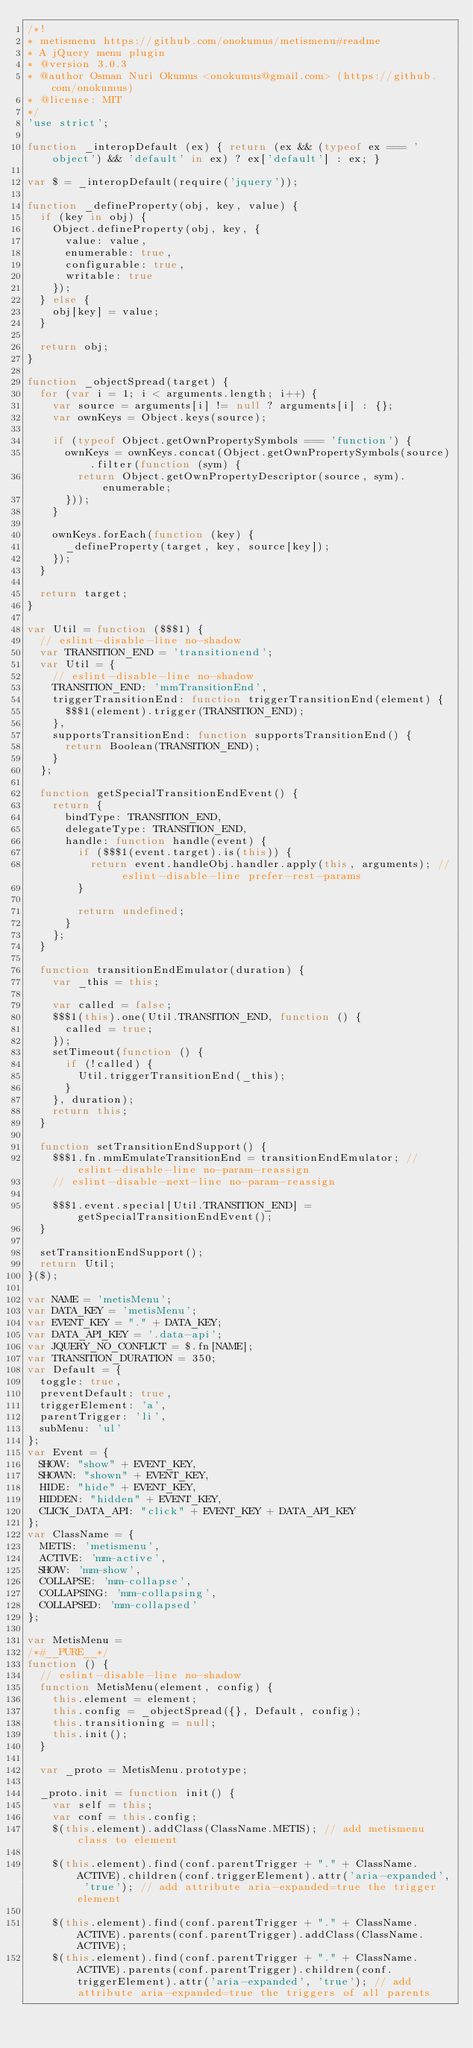<code> <loc_0><loc_0><loc_500><loc_500><_JavaScript_>/*!
* metismenu https://github.com/onokumus/metismenu#readme
* A jQuery menu plugin
* @version 3.0.3
* @author Osman Nuri Okumus <onokumus@gmail.com> (https://github.com/onokumus)
* @license: MIT 
*/
'use strict';

function _interopDefault (ex) { return (ex && (typeof ex === 'object') && 'default' in ex) ? ex['default'] : ex; }

var $ = _interopDefault(require('jquery'));

function _defineProperty(obj, key, value) {
  if (key in obj) {
    Object.defineProperty(obj, key, {
      value: value,
      enumerable: true,
      configurable: true,
      writable: true
    });
  } else {
    obj[key] = value;
  }

  return obj;
}

function _objectSpread(target) {
  for (var i = 1; i < arguments.length; i++) {
    var source = arguments[i] != null ? arguments[i] : {};
    var ownKeys = Object.keys(source);

    if (typeof Object.getOwnPropertySymbols === 'function') {
      ownKeys = ownKeys.concat(Object.getOwnPropertySymbols(source).filter(function (sym) {
        return Object.getOwnPropertyDescriptor(source, sym).enumerable;
      }));
    }

    ownKeys.forEach(function (key) {
      _defineProperty(target, key, source[key]);
    });
  }

  return target;
}

var Util = function ($$$1) {
  // eslint-disable-line no-shadow
  var TRANSITION_END = 'transitionend';
  var Util = {
    // eslint-disable-line no-shadow
    TRANSITION_END: 'mmTransitionEnd',
    triggerTransitionEnd: function triggerTransitionEnd(element) {
      $$$1(element).trigger(TRANSITION_END);
    },
    supportsTransitionEnd: function supportsTransitionEnd() {
      return Boolean(TRANSITION_END);
    }
  };

  function getSpecialTransitionEndEvent() {
    return {
      bindType: TRANSITION_END,
      delegateType: TRANSITION_END,
      handle: function handle(event) {
        if ($$$1(event.target).is(this)) {
          return event.handleObj.handler.apply(this, arguments); // eslint-disable-line prefer-rest-params
        }

        return undefined;
      }
    };
  }

  function transitionEndEmulator(duration) {
    var _this = this;

    var called = false;
    $$$1(this).one(Util.TRANSITION_END, function () {
      called = true;
    });
    setTimeout(function () {
      if (!called) {
        Util.triggerTransitionEnd(_this);
      }
    }, duration);
    return this;
  }

  function setTransitionEndSupport() {
    $$$1.fn.mmEmulateTransitionEnd = transitionEndEmulator; // eslint-disable-line no-param-reassign
    // eslint-disable-next-line no-param-reassign

    $$$1.event.special[Util.TRANSITION_END] = getSpecialTransitionEndEvent();
  }

  setTransitionEndSupport();
  return Util;
}($);

var NAME = 'metisMenu';
var DATA_KEY = 'metisMenu';
var EVENT_KEY = "." + DATA_KEY;
var DATA_API_KEY = '.data-api';
var JQUERY_NO_CONFLICT = $.fn[NAME];
var TRANSITION_DURATION = 350;
var Default = {
  toggle: true,
  preventDefault: true,
  triggerElement: 'a',
  parentTrigger: 'li',
  subMenu: 'ul'
};
var Event = {
  SHOW: "show" + EVENT_KEY,
  SHOWN: "shown" + EVENT_KEY,
  HIDE: "hide" + EVENT_KEY,
  HIDDEN: "hidden" + EVENT_KEY,
  CLICK_DATA_API: "click" + EVENT_KEY + DATA_API_KEY
};
var ClassName = {
  METIS: 'metismenu',
  ACTIVE: 'mm-active',
  SHOW: 'mm-show',
  COLLAPSE: 'mm-collapse',
  COLLAPSING: 'mm-collapsing',
  COLLAPSED: 'mm-collapsed'
};

var MetisMenu =
/*#__PURE__*/
function () {
  // eslint-disable-line no-shadow
  function MetisMenu(element, config) {
    this.element = element;
    this.config = _objectSpread({}, Default, config);
    this.transitioning = null;
    this.init();
  }

  var _proto = MetisMenu.prototype;

  _proto.init = function init() {
    var self = this;
    var conf = this.config;
    $(this.element).addClass(ClassName.METIS); // add metismenu class to element

    $(this.element).find(conf.parentTrigger + "." + ClassName.ACTIVE).children(conf.triggerElement).attr('aria-expanded', 'true'); // add attribute aria-expanded=true the trigger element

    $(this.element).find(conf.parentTrigger + "." + ClassName.ACTIVE).parents(conf.parentTrigger).addClass(ClassName.ACTIVE);
    $(this.element).find(conf.parentTrigger + "." + ClassName.ACTIVE).parents(conf.parentTrigger).children(conf.triggerElement).attr('aria-expanded', 'true'); // add attribute aria-expanded=true the triggers of all parents
</code> 